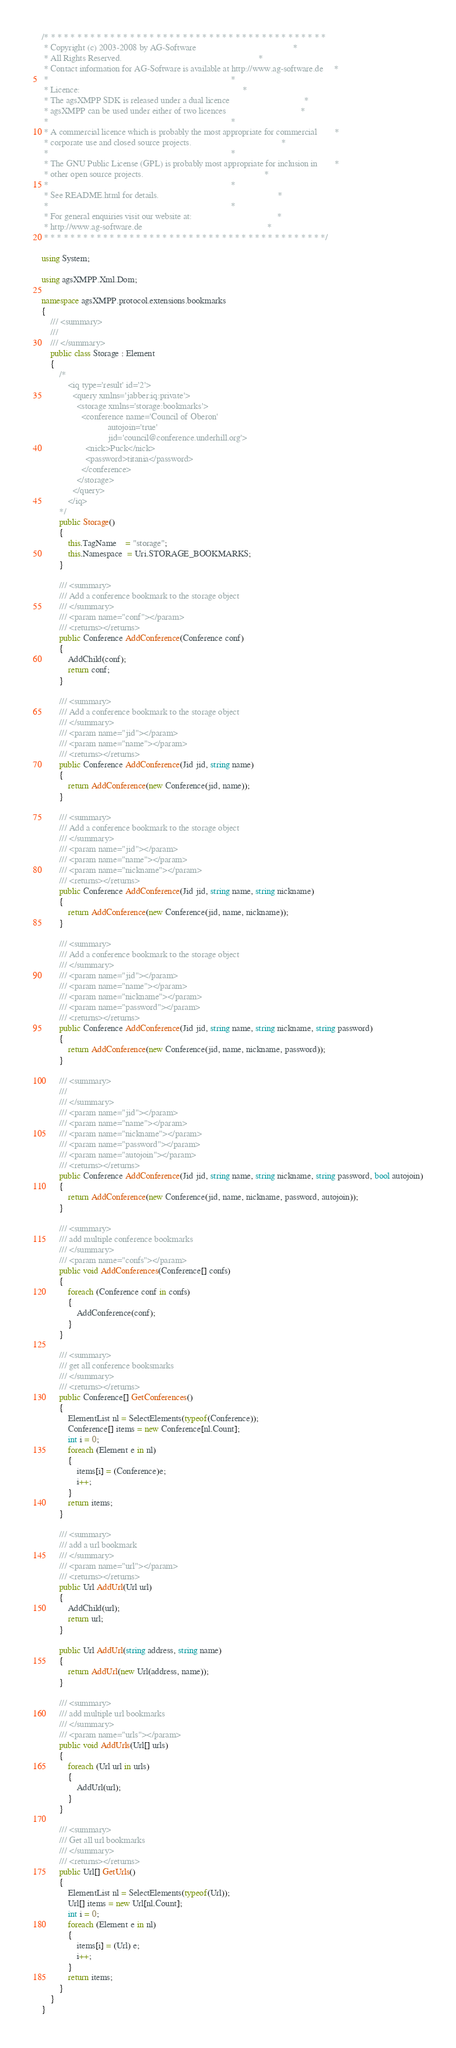<code> <loc_0><loc_0><loc_500><loc_500><_C#_>/* * * * * * * * * * * * * * * * * * * * * * * * * * * * * * * * * * * * * * * * * * *
 * Copyright (c) 2003-2008 by AG-Software 											 *
 * All Rights Reserved.																 *
 * Contact information for AG-Software is available at http://www.ag-software.de	 *
 *																					 *
 * Licence:																			 *
 * The agsXMPP SDK is released under a dual licence									 *
 * agsXMPP can be used under either of two licences									 *
 * 																					 *
 * A commercial licence which is probably the most appropriate for commercial 		 *
 * corporate use and closed source projects. 										 *
 *																					 *
 * The GNU Public License (GPL) is probably most appropriate for inclusion in		 *
 * other open source projects.														 *
 *																					 *
 * See README.html for details.														 *
 *																					 *
 * For general enquiries visit our website at:										 *
 * http://www.ag-software.de														 *
 * * * * * * * * * * * * * * * * * * * * * * * * * * * * * * * * * * * * * * * * * * */

using System;

using agsXMPP.Xml.Dom;

namespace agsXMPP.protocol.extensions.bookmarks
{
    /// <summary>
    /// 
    /// </summary>
    public class Storage : Element
    {
        /*
            <iq type='result' id='2'>
              <query xmlns='jabber:iq:private'>
                <storage xmlns='storage:bookmarks'>
                  <conference name='Council of Oberon' 
                              autojoin='true'
                              jid='council@conference.underhill.org'>
                    <nick>Puck</nick>
                    <password>titania</password>
                  </conference>
                </storage>
              </query>
            </iq>   
        */
        public Storage()
        {
            this.TagName    = "storage";
            this.Namespace  = Uri.STORAGE_BOOKMARKS;
        }
        
        /// <summary>
        /// Add a conference bookmark to the storage object
        /// </summary>
        /// <param name="conf"></param>
        /// <returns></returns>
        public Conference AddConference(Conference conf)
        {
            AddChild(conf);
            return conf;
        }

        /// <summary>
        /// Add a conference bookmark to the storage object
        /// </summary>
        /// <param name="jid"></param>
        /// <param name="name"></param>
        /// <returns></returns>
        public Conference AddConference(Jid jid, string name)
        {
            return AddConference(new Conference(jid, name));
        }

        /// <summary>
        /// Add a conference bookmark to the storage object
        /// </summary>
        /// <param name="jid"></param>
        /// <param name="name"></param>
        /// <param name="nickname"></param>
        /// <returns></returns>
        public Conference AddConference(Jid jid, string name, string nickname)
        {
            return AddConference(new Conference(jid, name, nickname));
        }

        /// <summary>
        /// Add a conference bookmark to the storage object
        /// </summary>
        /// <param name="jid"></param>
        /// <param name="name"></param>
        /// <param name="nickname"></param>
        /// <param name="password"></param>
        /// <returns></returns>
        public Conference AddConference(Jid jid, string name, string nickname, string password)
        {
            return AddConference(new Conference(jid, name, nickname, password));
        }

        /// <summary>
        /// 
        /// </summary>
        /// <param name="jid"></param>
        /// <param name="name"></param>
        /// <param name="nickname"></param>
        /// <param name="password"></param>
        /// <param name="autojoin"></param>
        /// <returns></returns>
        public Conference AddConference(Jid jid, string name, string nickname, string password, bool autojoin)
        {
            return AddConference(new Conference(jid, name, nickname, password, autojoin));
        }

        /// <summary>
        /// add multiple conference bookmarks
        /// </summary>
        /// <param name="confs"></param>
        public void AddConferences(Conference[] confs)
        {
            foreach (Conference conf in confs)
            {
                AddConference(conf);
            }
        }

        /// <summary>
        /// get all conference booksmarks
        /// </summary>
        /// <returns></returns>
        public Conference[] GetConferences()
        {
            ElementList nl = SelectElements(typeof(Conference));
            Conference[] items = new Conference[nl.Count];
            int i = 0;
            foreach (Element e in nl)
            {
                items[i] = (Conference)e;
                i++;
            }
            return items;
        }

        /// <summary>
        /// add a url bookmark
        /// </summary>
        /// <param name="url"></param>
        /// <returns></returns>
        public Url AddUrl(Url url)
        {
            AddChild(url);
            return url;
        }

        public Url AddUrl(string address, string name)
        {
            return AddUrl(new Url(address, name));            
        }

        /// <summary>
        /// add multiple url bookmarks
        /// </summary>
        /// <param name="urls"></param>
        public void AddUrls(Url[] urls)
        {
            foreach (Url url in urls)
            {
                AddUrl(url);
            }           
        }

        /// <summary>
        /// Get all url bookmarks
        /// </summary>
        /// <returns></returns>
        public Url[] GetUrls()
        {
            ElementList nl = SelectElements(typeof(Url));
            Url[] items = new Url[nl.Count];
            int i = 0;
            foreach (Element e in nl)
            {
                items[i] = (Url) e;
                i++;
            }
            return items;
        }
    }
}
</code> 